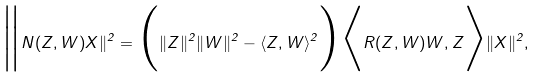Convert formula to latex. <formula><loc_0><loc_0><loc_500><loc_500>\Big { \| } N ( Z , W ) X \| ^ { 2 } = \Big { ( } \| Z \| ^ { 2 } \| W \| ^ { 2 } - \langle Z , W \rangle ^ { 2 } \Big { ) } \Big { \langle } R ( Z , W ) W , Z \Big { \rangle } \| X \| ^ { 2 } ,</formula> 